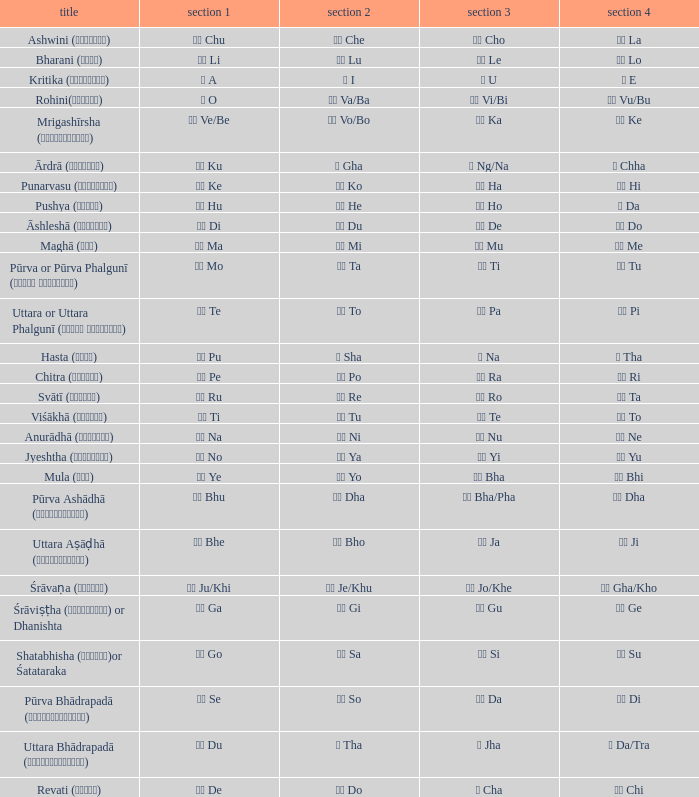Which pada 3 has a pada 2 of चे che? चो Cho. 